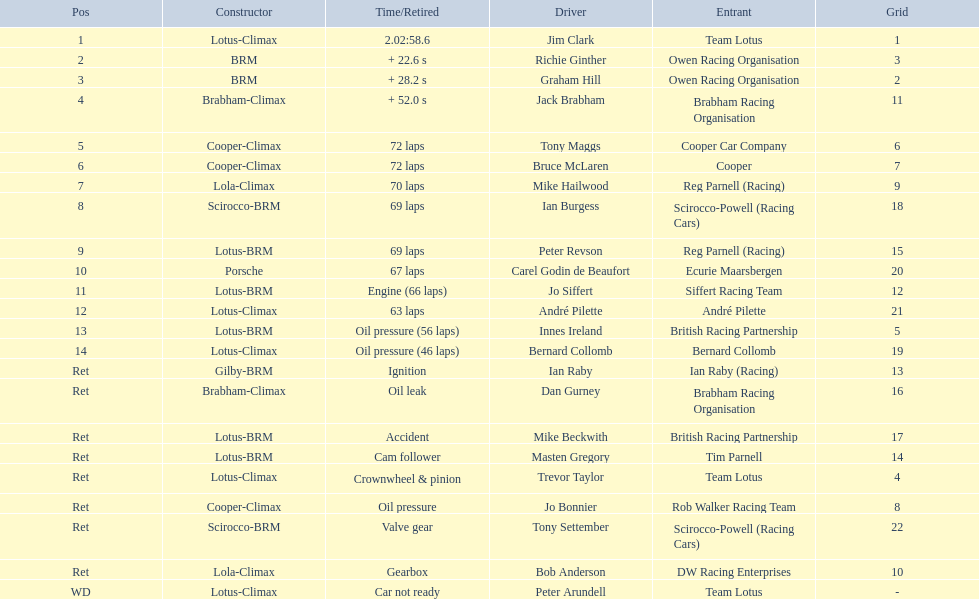Who were the drivers at the 1963 international gold cup? Jim Clark, Richie Ginther, Graham Hill, Jack Brabham, Tony Maggs, Bruce McLaren, Mike Hailwood, Ian Burgess, Peter Revson, Carel Godin de Beaufort, Jo Siffert, André Pilette, Innes Ireland, Bernard Collomb, Ian Raby, Dan Gurney, Mike Beckwith, Masten Gregory, Trevor Taylor, Jo Bonnier, Tony Settember, Bob Anderson, Peter Arundell. What was tony maggs position? 5. What was jo siffert? 11. Who came in earlier? Tony Maggs. 